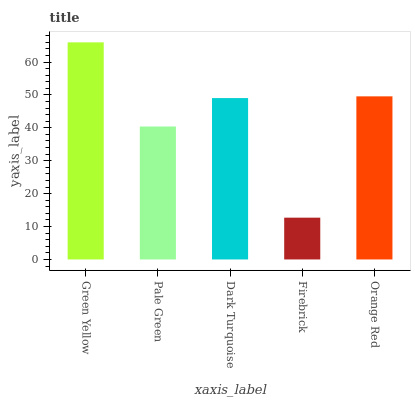Is Firebrick the minimum?
Answer yes or no. Yes. Is Green Yellow the maximum?
Answer yes or no. Yes. Is Pale Green the minimum?
Answer yes or no. No. Is Pale Green the maximum?
Answer yes or no. No. Is Green Yellow greater than Pale Green?
Answer yes or no. Yes. Is Pale Green less than Green Yellow?
Answer yes or no. Yes. Is Pale Green greater than Green Yellow?
Answer yes or no. No. Is Green Yellow less than Pale Green?
Answer yes or no. No. Is Dark Turquoise the high median?
Answer yes or no. Yes. Is Dark Turquoise the low median?
Answer yes or no. Yes. Is Orange Red the high median?
Answer yes or no. No. Is Green Yellow the low median?
Answer yes or no. No. 